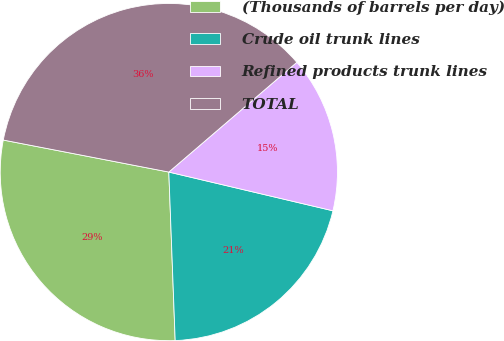Convert chart to OTSL. <chart><loc_0><loc_0><loc_500><loc_500><pie_chart><fcel>(Thousands of barrels per day)<fcel>Crude oil trunk lines<fcel>Refined products trunk lines<fcel>TOTAL<nl><fcel>28.64%<fcel>20.71%<fcel>14.97%<fcel>35.68%<nl></chart> 